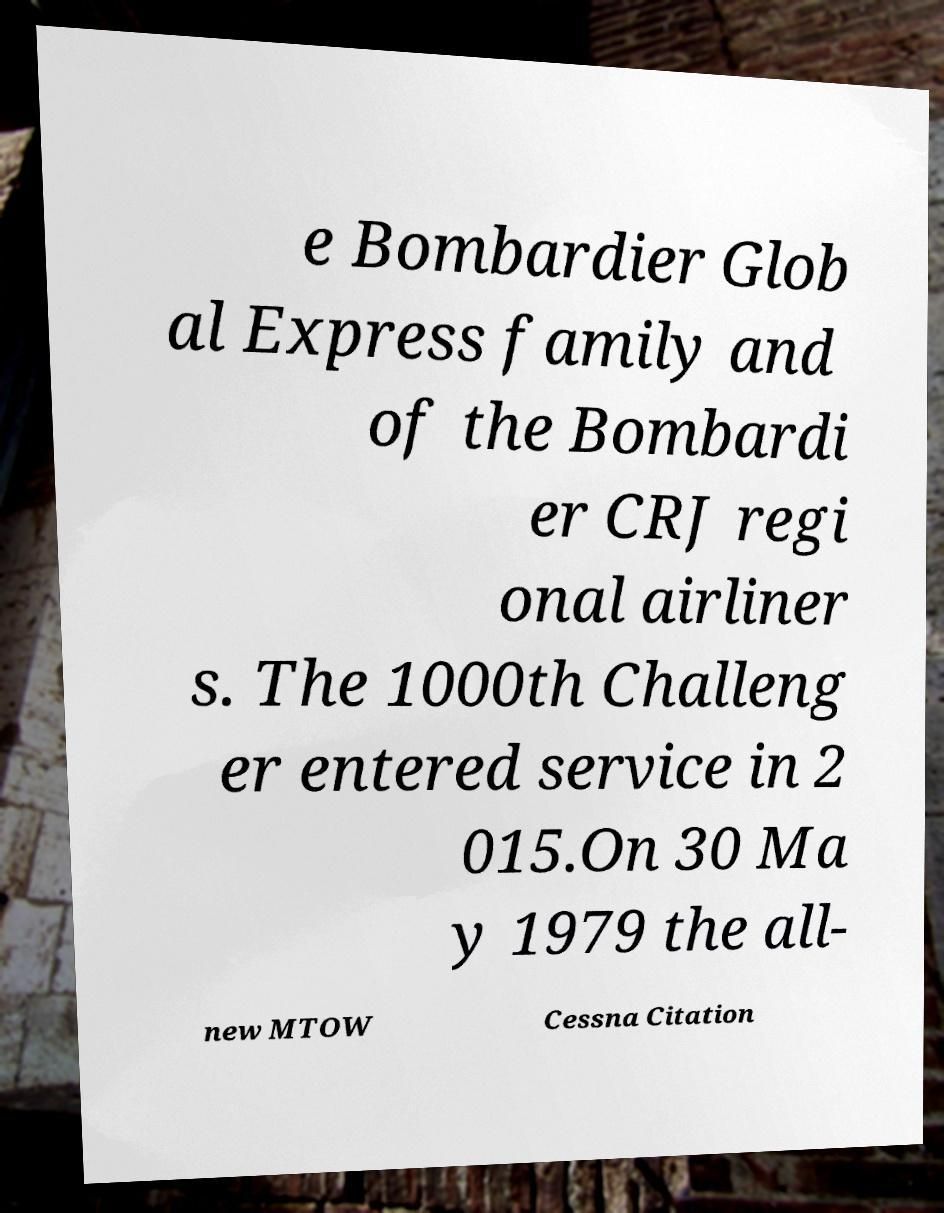I need the written content from this picture converted into text. Can you do that? e Bombardier Glob al Express family and of the Bombardi er CRJ regi onal airliner s. The 1000th Challeng er entered service in 2 015.On 30 Ma y 1979 the all- new MTOW Cessna Citation 